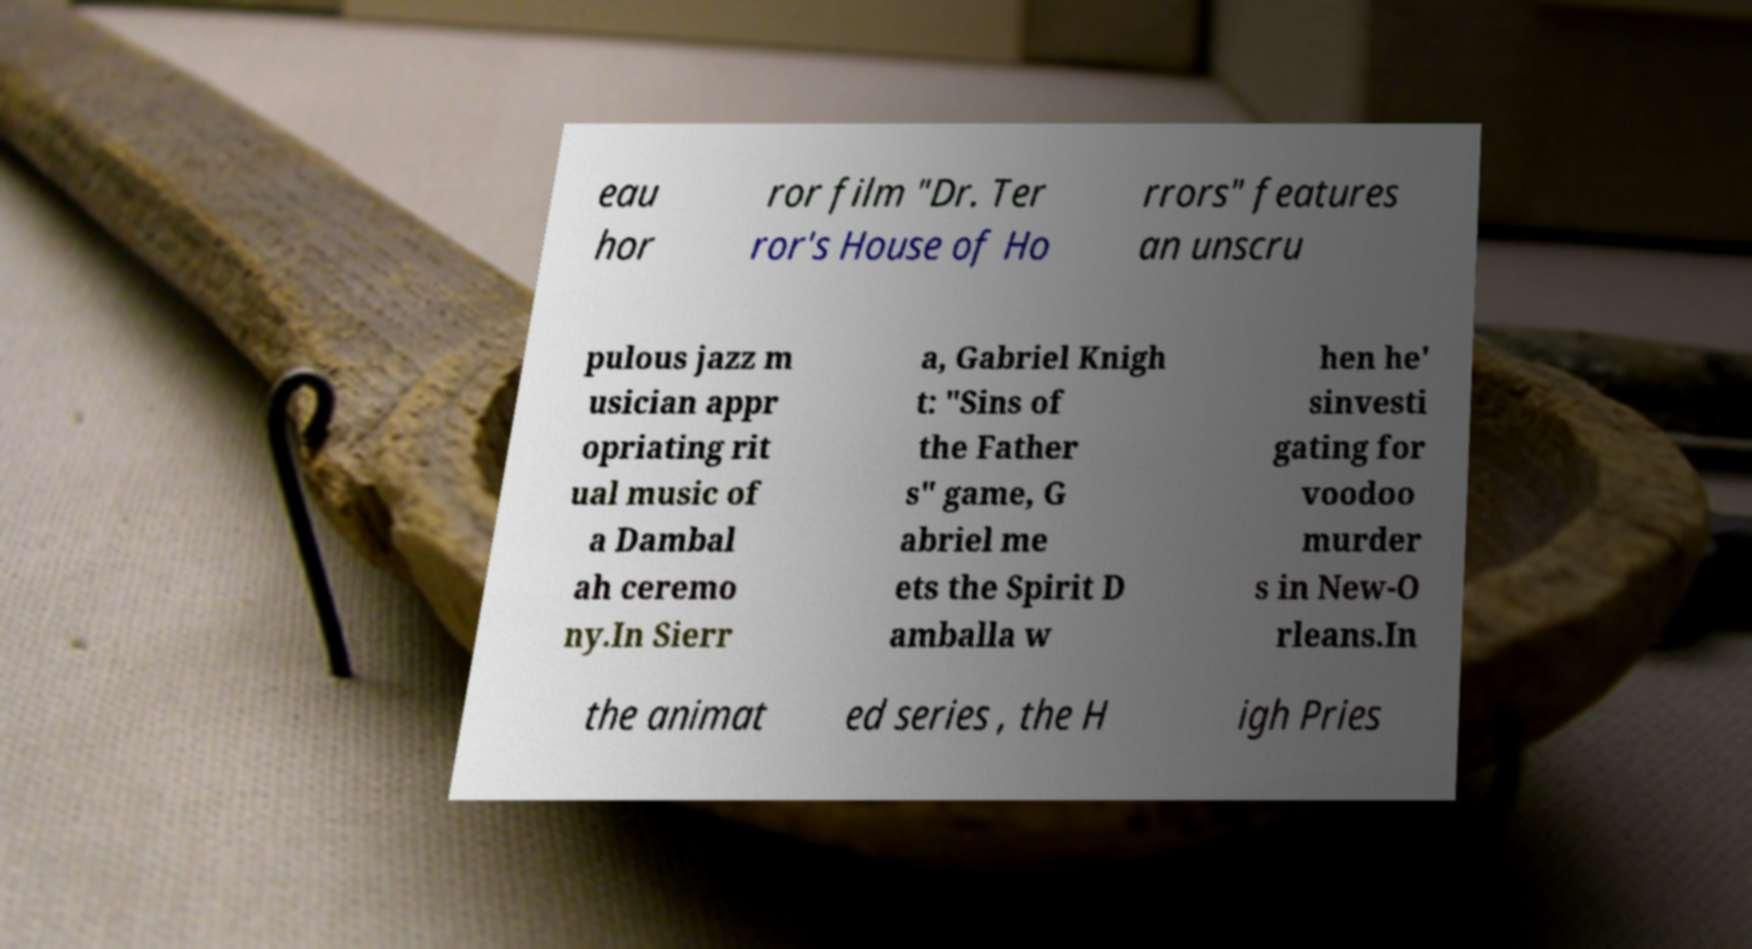Can you accurately transcribe the text from the provided image for me? eau hor ror film "Dr. Ter ror's House of Ho rrors" features an unscru pulous jazz m usician appr opriating rit ual music of a Dambal ah ceremo ny.In Sierr a, Gabriel Knigh t: "Sins of the Father s" game, G abriel me ets the Spirit D amballa w hen he' sinvesti gating for voodoo murder s in New-O rleans.In the animat ed series , the H igh Pries 